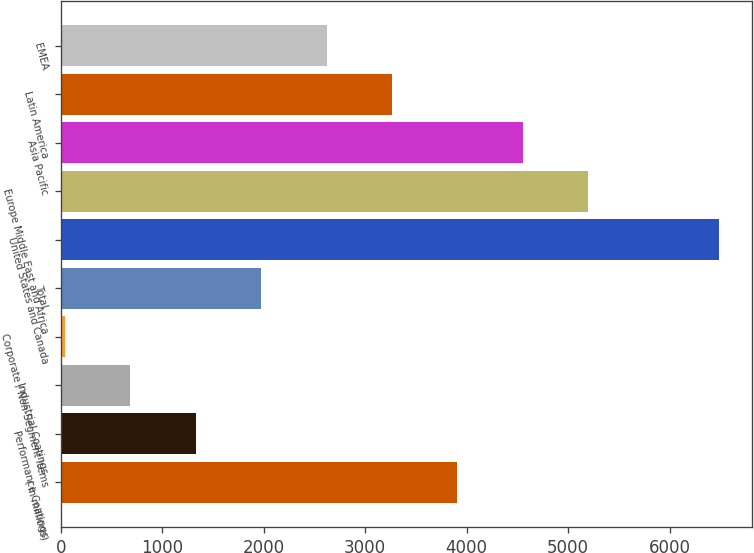<chart> <loc_0><loc_0><loc_500><loc_500><bar_chart><fcel>( in millions)<fcel>Performance Coatings<fcel>Industrial Coatings<fcel>Corporate / Non-Segment Items<fcel>Total<fcel>United States and Canada<fcel>Europe Middle East and Africa<fcel>Asia Pacific<fcel>Latin America<fcel>EMEA<nl><fcel>3907.8<fcel>1330.6<fcel>686.3<fcel>42<fcel>1974.9<fcel>6485<fcel>5196.4<fcel>4552.1<fcel>3263.5<fcel>2619.2<nl></chart> 